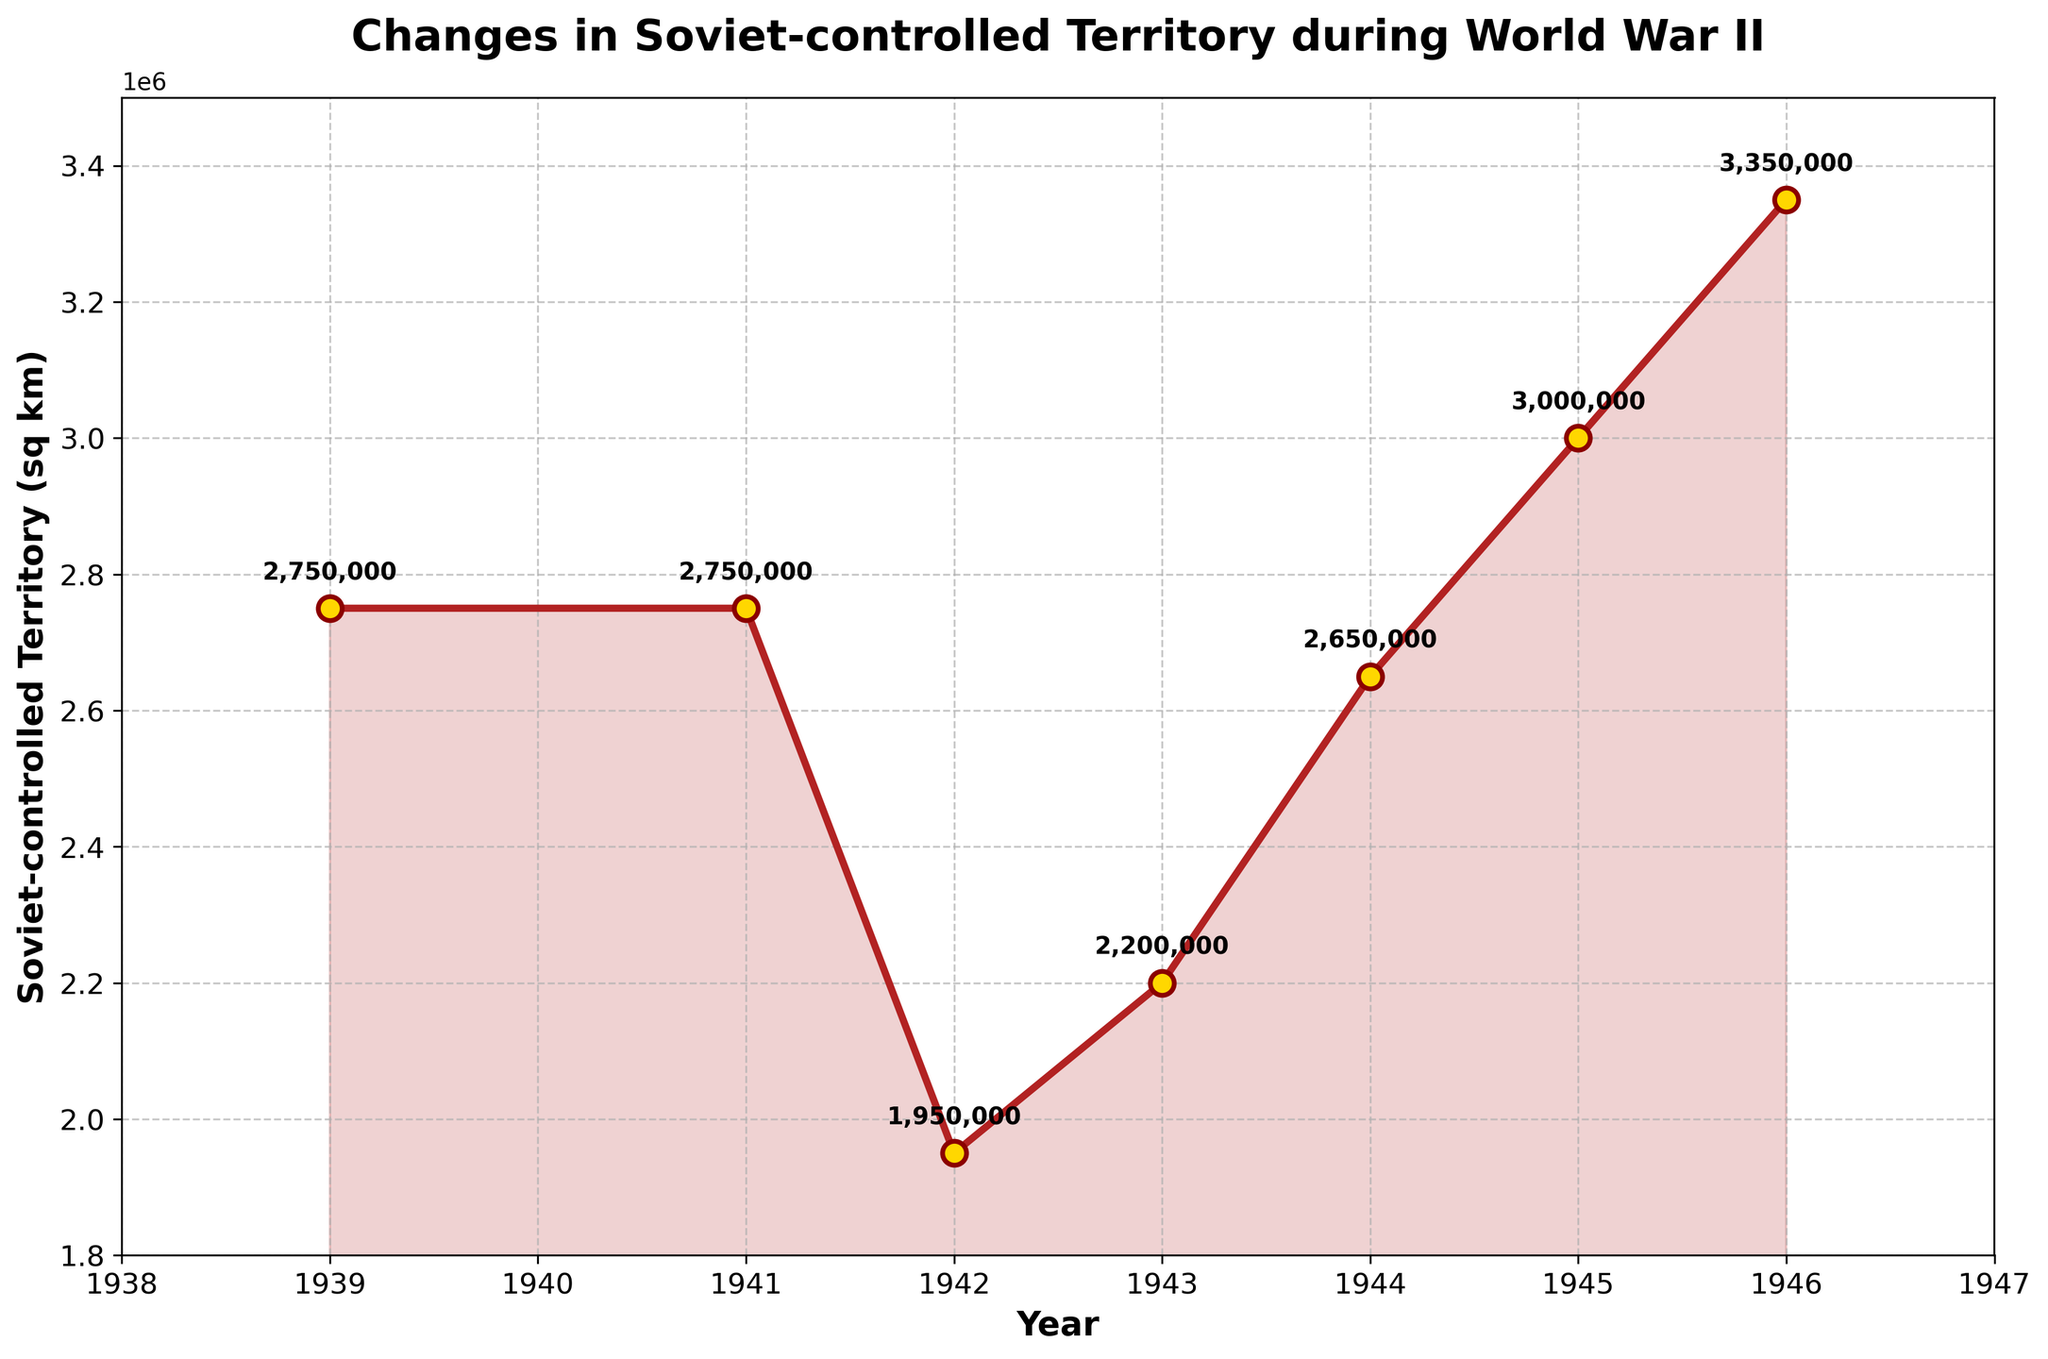What is the trend in Soviet-controlled territory from 1939 to 1942? Between 1939 and 1941, the Soviet-controlled territory remained stable at 2,750,000 sq km. However, in 1942, it decreased to 1,950,000 sq km.
Answer: Decreasing How does the Soviet-controlled territory in 1945 compare to that in 1942? In 1942, the Soviet-controlled territory was 1,950,000 sq km. By 1945, it had increased to 3,000,000 sq km.
Answer: Increased What year shows the lowest Soviet-controlled territory and what was the value? The lowest Soviet-controlled territory was in 1942 with a value of 1,950,000 sq km.
Answer: 1942, 1,950,000 sq km What was the difference in Soviet-controlled territory between 1939 and 1945? In 1939, the territory was 2,750,000 sq km. By 1945, it was 3,000,000 sq km. The difference is 3,000,000 - 2,750,000 = 250,000 sq km.
Answer: 250,000 sq km Between which consecutive years did the Soviet-controlled territory increase the most? The largest increase occurred between 1945 and 1946, where the territory increased from 3,000,000 to 3,350,000 sq km, a difference of 350,000 sq km.
Answer: 1945 and 1946 What was the average Soviet-controlled territory during the years 1939, 1941, and 1946? The territories for these years are 2,750,000 (1939), 2,750,000 (1941), and 3,350,000 (1946). The average is (2,750,000 + 2,750,000 + 3,350,000) / 3 = 2,950,000 sq km.
Answer: 2,950,000 sq km By how much did the Soviet-controlled territory change from 1943 to 1944? In 1943, the territory was 2,200,000 sq km, and in 1944, it was 2,650,000 sq km. The change is 2,650,000 - 2,200,000 = 450,000 sq km.
Answer: 450,000 sq km What was the trend in Soviet-controlled territory from 1944 to 1946? The Soviet-controlled territory consistently increased during this period: from 2,650,000 sq km in 1944 to 3,350,000 sq km in 1946.
Answer: Increasing Between which consecutive years did the Soviet-controlled territory decrease and what were the values? The territory decreased between 1941 and 1942, from 2,750,000 sq km to 1,950,000 sq km.
Answer: 1941 to 1942, 2,750,000 sq km to 1,950,000 sq km What is the median value of the Soviet-controlled territory during the given years? The values in ascending order are 1,950,000, 2,200,000, 2,650,000, 2,750,000, 2,750,000, 3,000,000, 3,350,000. The median is the middle value, which is 2,750,000 sq km.
Answer: 2,750,000 sq km 